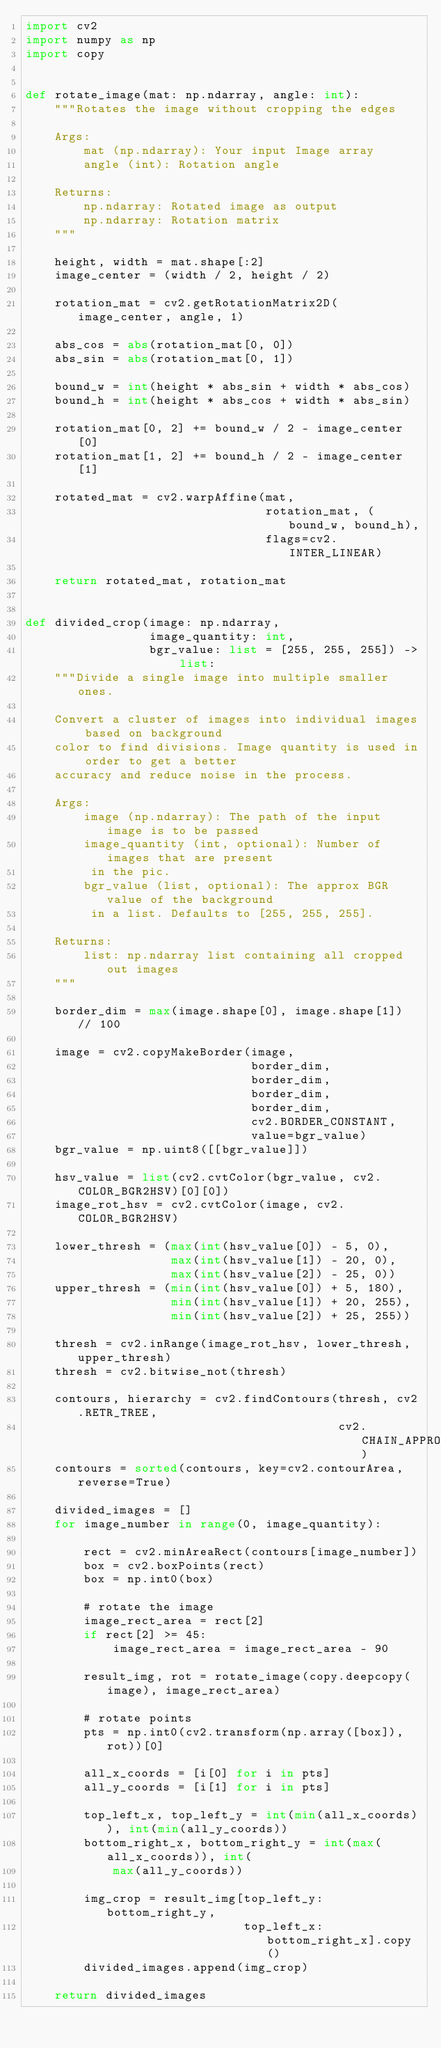Convert code to text. <code><loc_0><loc_0><loc_500><loc_500><_Python_>import cv2
import numpy as np
import copy


def rotate_image(mat: np.ndarray, angle: int):
    """Rotates the image without cropping the edges

    Args:
        mat (np.ndarray): Your input Image array
        angle (int): Rotation angle

    Returns:
        np.ndarray: Rotated image as output
        np.ndarray: Rotation matrix
    """

    height, width = mat.shape[:2]
    image_center = (width / 2, height / 2)

    rotation_mat = cv2.getRotationMatrix2D(image_center, angle, 1)

    abs_cos = abs(rotation_mat[0, 0])
    abs_sin = abs(rotation_mat[0, 1])

    bound_w = int(height * abs_sin + width * abs_cos)
    bound_h = int(height * abs_cos + width * abs_sin)

    rotation_mat[0, 2] += bound_w / 2 - image_center[0]
    rotation_mat[1, 2] += bound_h / 2 - image_center[1]

    rotated_mat = cv2.warpAffine(mat,
                                 rotation_mat, (bound_w, bound_h),
                                 flags=cv2.INTER_LINEAR)

    return rotated_mat, rotation_mat


def divided_crop(image: np.ndarray,
                 image_quantity: int,
                 bgr_value: list = [255, 255, 255]) -> list:
    """Divide a single image into multiple smaller ones.

    Convert a cluster of images into individual images based on background
    color to find divisions. Image quantity is used in order to get a better
    accuracy and reduce noise in the process.

    Args:
        image (np.ndarray): The path of the input image is to be passed
        image_quantity (int, optional): Number of images that are present
         in the pic.
        bgr_value (list, optional): The approx BGR value of the background
         in a list. Defaults to [255, 255, 255].

    Returns:
        list: np.ndarray list containing all cropped out images
    """

    border_dim = max(image.shape[0], image.shape[1]) // 100

    image = cv2.copyMakeBorder(image,
                               border_dim,
                               border_dim,
                               border_dim,
                               border_dim,
                               cv2.BORDER_CONSTANT,
                               value=bgr_value)
    bgr_value = np.uint8([[bgr_value]])

    hsv_value = list(cv2.cvtColor(bgr_value, cv2.COLOR_BGR2HSV)[0][0])
    image_rot_hsv = cv2.cvtColor(image, cv2.COLOR_BGR2HSV)

    lower_thresh = (max(int(hsv_value[0]) - 5, 0),
                    max(int(hsv_value[1]) - 20, 0),
                    max(int(hsv_value[2]) - 25, 0))
    upper_thresh = (min(int(hsv_value[0]) + 5, 180),
                    min(int(hsv_value[1]) + 20, 255),
                    min(int(hsv_value[2]) + 25, 255))

    thresh = cv2.inRange(image_rot_hsv, lower_thresh, upper_thresh)
    thresh = cv2.bitwise_not(thresh)

    contours, hierarchy = cv2.findContours(thresh, cv2.RETR_TREE,
                                           cv2.CHAIN_APPROX_SIMPLE)
    contours = sorted(contours, key=cv2.contourArea, reverse=True)

    divided_images = []
    for image_number in range(0, image_quantity):

        rect = cv2.minAreaRect(contours[image_number])
        box = cv2.boxPoints(rect)
        box = np.int0(box)

        # rotate the image
        image_rect_area = rect[2]
        if rect[2] >= 45:
            image_rect_area = image_rect_area - 90

        result_img, rot = rotate_image(copy.deepcopy(image), image_rect_area)

        # rotate points
        pts = np.int0(cv2.transform(np.array([box]), rot))[0]

        all_x_coords = [i[0] for i in pts]
        all_y_coords = [i[1] for i in pts]

        top_left_x, top_left_y = int(min(all_x_coords)), int(min(all_y_coords))
        bottom_right_x, bottom_right_y = int(max(all_x_coords)), int(
            max(all_y_coords))

        img_crop = result_img[top_left_y:bottom_right_y,
                              top_left_x:bottom_right_x].copy()
        divided_images.append(img_crop)

    return divided_images
</code> 